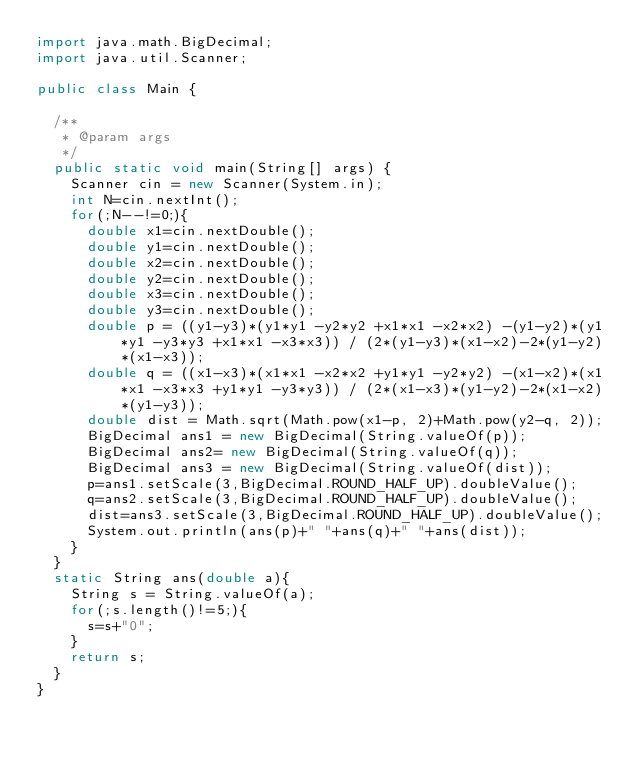<code> <loc_0><loc_0><loc_500><loc_500><_Java_>import java.math.BigDecimal;
import java.util.Scanner;

public class Main {

	/**
	 * @param args
	 */
	public static void main(String[] args) {
		Scanner cin = new Scanner(System.in);
		int N=cin.nextInt();
		for(;N--!=0;){
			double x1=cin.nextDouble();
			double y1=cin.nextDouble();
			double x2=cin.nextDouble();
			double y2=cin.nextDouble();
			double x3=cin.nextDouble();
			double y3=cin.nextDouble();
			double p = ((y1-y3)*(y1*y1 -y2*y2 +x1*x1 -x2*x2) -(y1-y2)*(y1*y1 -y3*y3 +x1*x1 -x3*x3)) / (2*(y1-y3)*(x1-x2)-2*(y1-y2)*(x1-x3));
			double q = ((x1-x3)*(x1*x1 -x2*x2 +y1*y1 -y2*y2) -(x1-x2)*(x1*x1 -x3*x3 +y1*y1 -y3*y3)) / (2*(x1-x3)*(y1-y2)-2*(x1-x2)*(y1-y3));
			double dist = Math.sqrt(Math.pow(x1-p, 2)+Math.pow(y2-q, 2));
			BigDecimal ans1 = new BigDecimal(String.valueOf(p));
			BigDecimal ans2= new BigDecimal(String.valueOf(q));
			BigDecimal ans3 = new BigDecimal(String.valueOf(dist));
			p=ans1.setScale(3,BigDecimal.ROUND_HALF_UP).doubleValue();
			q=ans2.setScale(3,BigDecimal.ROUND_HALF_UP).doubleValue();
			dist=ans3.setScale(3,BigDecimal.ROUND_HALF_UP).doubleValue();
			System.out.println(ans(p)+" "+ans(q)+" "+ans(dist));
		}
	}
	static String ans(double a){
		String s = String.valueOf(a);
		for(;s.length()!=5;){
			s=s+"0";
		}
		return s;
	}
}</code> 